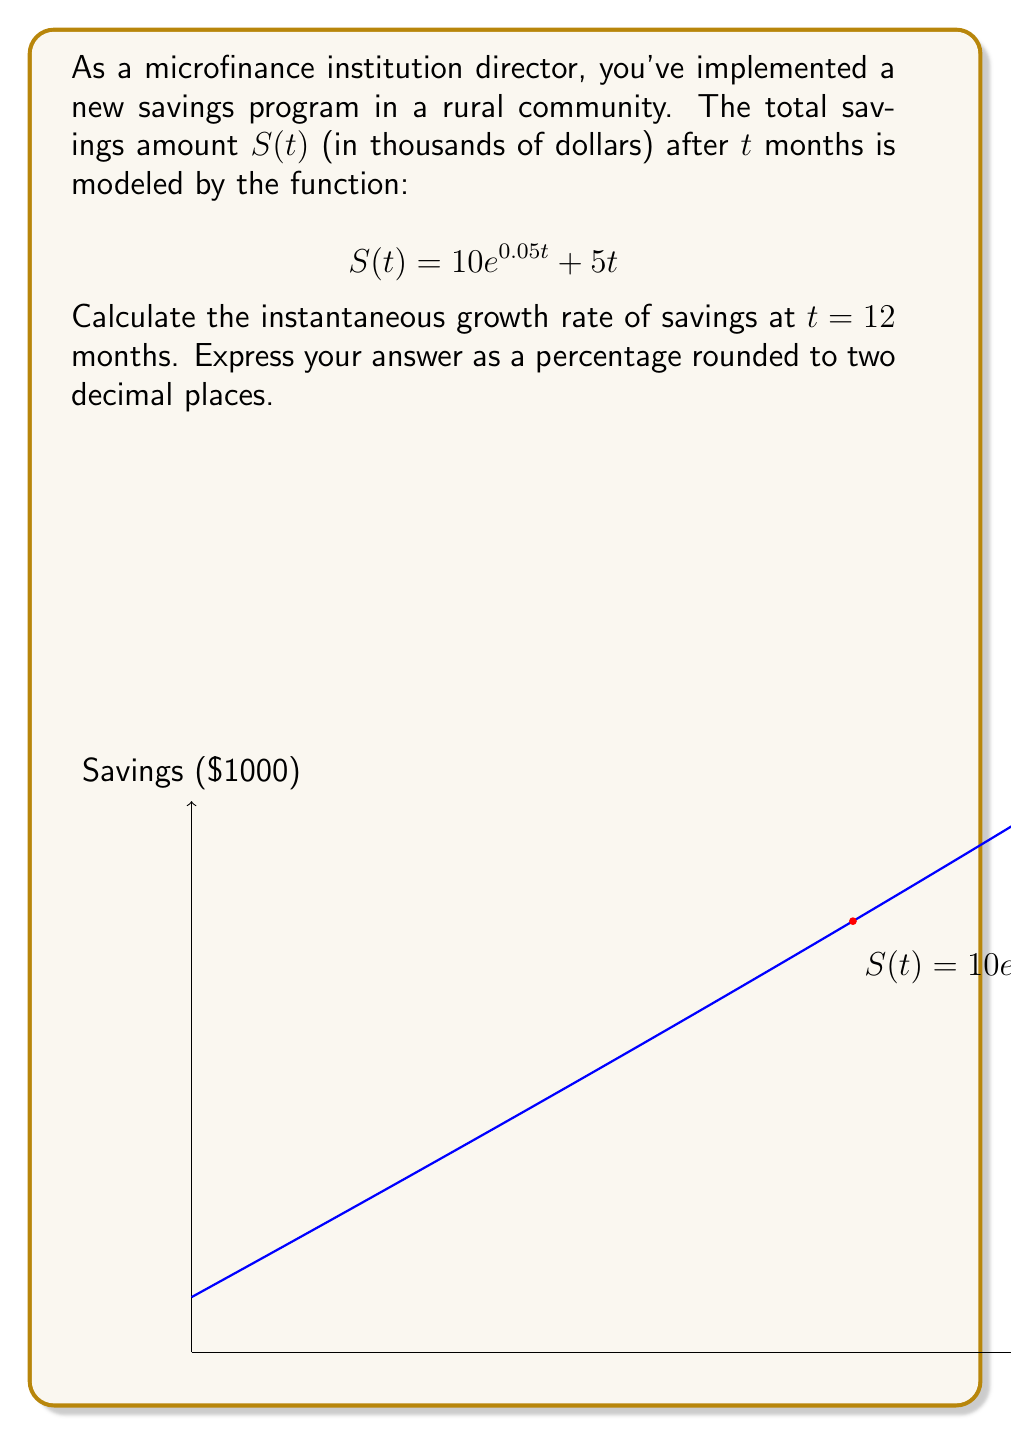Provide a solution to this math problem. To find the instantaneous growth rate, we need to calculate the derivative of $S(t)$ and evaluate it at $t = 12$. Then, we'll express it as a percentage of the total savings at that time.

Step 1: Calculate $S'(t)$
$$S'(t) = \frac{d}{dt}(10e^{0.05t} + 5t) = 10 \cdot 0.05e^{0.05t} + 5 = 0.5e^{0.05t} + 5$$

Step 2: Evaluate $S'(12)$
$$S'(12) = 0.5e^{0.05 \cdot 12} + 5 = 0.5e^{0.6} + 5 \approx 5.9112$$

Step 3: Calculate $S(12)$
$$S(12) = 10e^{0.05 \cdot 12} + 5 \cdot 12 = 10e^{0.6} + 60 \approx 82.2240$$

Step 4: Calculate the growth rate as a percentage
Growth rate = $\frac{S'(12)}{S(12)} \cdot 100\%$
$= \frac{5.9112}{82.2240} \cdot 100\% \approx 7.19\%$

Therefore, the instantaneous growth rate at 12 months is approximately 7.19%.
Answer: 7.19% 